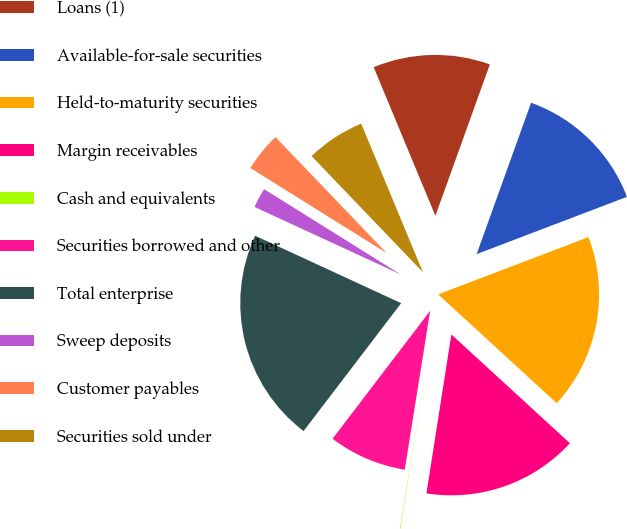Convert chart to OTSL. <chart><loc_0><loc_0><loc_500><loc_500><pie_chart><fcel>Loans (1)<fcel>Available-for-sale securities<fcel>Held-to-maturity securities<fcel>Margin receivables<fcel>Cash and equivalents<fcel>Securities borrowed and other<fcel>Total enterprise<fcel>Sweep deposits<fcel>Customer payables<fcel>Securities sold under<nl><fcel>11.76%<fcel>13.71%<fcel>17.61%<fcel>15.66%<fcel>0.05%<fcel>7.85%<fcel>21.51%<fcel>2.0%<fcel>3.95%<fcel>5.9%<nl></chart> 